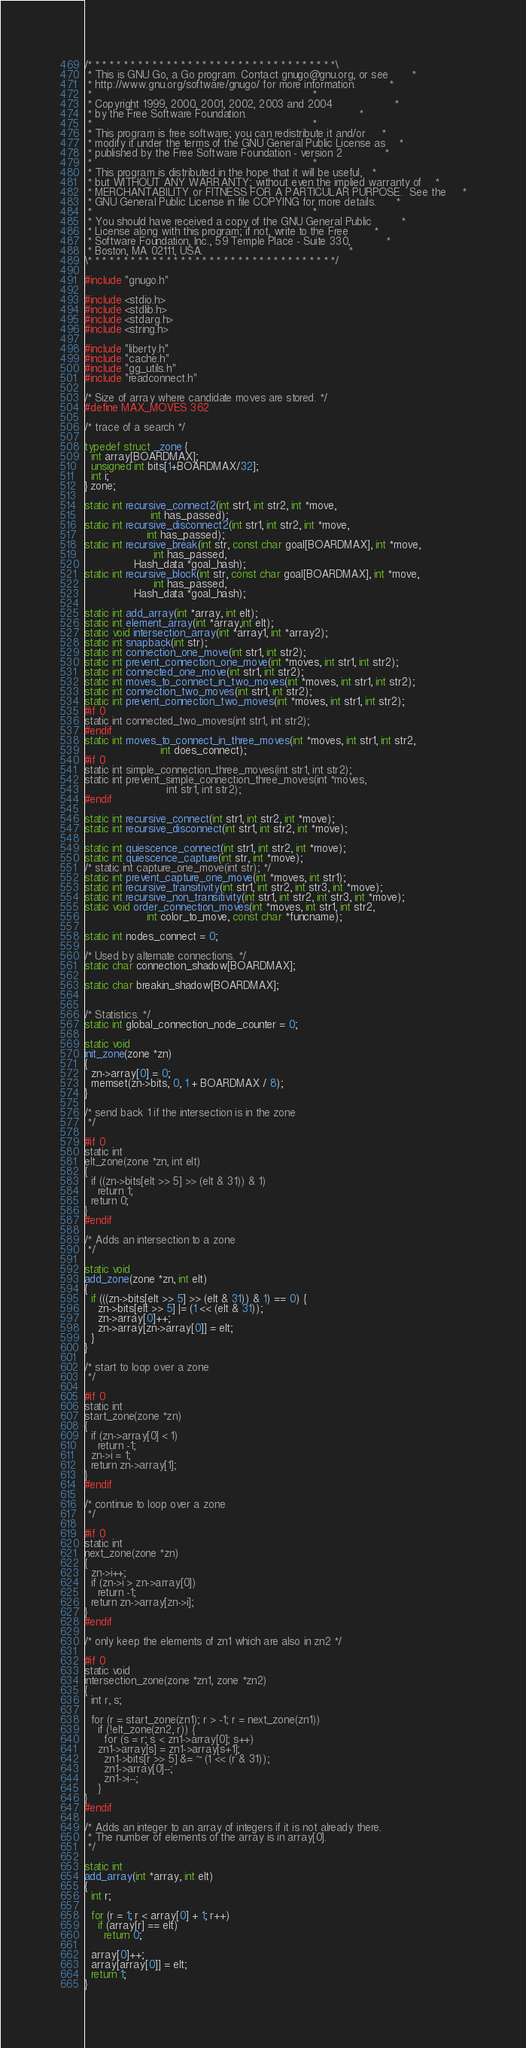Convert code to text. <code><loc_0><loc_0><loc_500><loc_500><_C_>/* * * * * * * * * * * * * * * * * * * * * * * * * * * * * * * * * * *\
 * This is GNU Go, a Go program. Contact gnugo@gnu.org, or see       *
 * http://www.gnu.org/software/gnugo/ for more information.          *
 *                                                                   *
 * Copyright 1999, 2000, 2001, 2002, 2003 and 2004                   *
 * by the Free Software Foundation.                                  *
 *                                                                   *
 * This program is free software; you can redistribute it and/or     *
 * modify it under the terms of the GNU General Public License as    *
 * published by the Free Software Foundation - version 2             *
 *                                                                   *
 * This program is distributed in the hope that it will be useful,   *
 * but WITHOUT ANY WARRANTY; without even the implied warranty of    *
 * MERCHANTABILITY or FITNESS FOR A PARTICULAR PURPOSE.  See the     *
 * GNU General Public License in file COPYING for more details.      *
 *                                                                   *
 * You should have received a copy of the GNU General Public         *
 * License along with this program; if not, write to the Free        *
 * Software Foundation, Inc., 59 Temple Place - Suite 330,           *
 * Boston, MA 02111, USA.                                            *
\* * * * * * * * * * * * * * * * * * * * * * * * * * * * * * * * * * */

#include "gnugo.h"

#include <stdio.h>
#include <stdlib.h>
#include <stdarg.h>
#include <string.h>

#include "liberty.h"
#include "cache.h"
#include "gg_utils.h"
#include "readconnect.h"

/* Size of array where candidate moves are stored. */
#define MAX_MOVES 362

/* trace of a search */

typedef struct _zone {
  int array[BOARDMAX];
  unsigned int bits[1+BOARDMAX/32];
  int i;
} zone;

static int recursive_connect2(int str1, int str2, int *move,
			        int has_passed);
static int recursive_disconnect2(int str1, int str2, int *move,
				   int has_passed);
static int recursive_break(int str, const char goal[BOARDMAX], int *move,
    			     int has_passed,
			   Hash_data *goal_hash);
static int recursive_block(int str, const char goal[BOARDMAX], int *move,
    			     int has_passed,
			   Hash_data *goal_hash);

static int add_array(int *array, int elt);
static int element_array(int *array,int elt);
static void intersection_array(int *array1, int *array2);
static int snapback(int str);
static int connection_one_move(int str1, int str2);
static int prevent_connection_one_move(int *moves, int str1, int str2);
static int connected_one_move(int str1, int str2);
static int moves_to_connect_in_two_moves(int *moves, int str1, int str2);
static int connection_two_moves(int str1, int str2);
static int prevent_connection_two_moves(int *moves, int str1, int str2);
#if 0
static int connected_two_moves(int str1, int str2);
#endif
static int moves_to_connect_in_three_moves(int *moves, int str1, int str2,
					   int does_connect);
#if 0
static int simple_connection_three_moves(int str1, int str2);
static int prevent_simple_connection_three_moves(int *moves,
						 int str1, int str2);
#endif

static int recursive_connect(int str1, int str2, int *move);
static int recursive_disconnect(int str1, int str2, int *move);

static int quiescence_connect(int str1, int str2, int *move);
static int quiescence_capture(int str, int *move);
/* static int capture_one_move(int str); */
static int prevent_capture_one_move(int *moves, int str1);
static int recursive_transitivity(int str1, int str2, int str3, int *move);
static int recursive_non_transitivity(int str1, int str2, int str3, int *move);
static void order_connection_moves(int *moves, int str1, int str2,
				   int color_to_move, const char *funcname);

static int nodes_connect = 0;

/* Used by alternate connections. */
static char connection_shadow[BOARDMAX];

static char breakin_shadow[BOARDMAX];


/* Statistics. */
static int global_connection_node_counter = 0;

static void
init_zone(zone *zn)
{
  zn->array[0] = 0;
  memset(zn->bits, 0, 1 + BOARDMAX / 8);
}

/* send back 1 if the intersection is in the zone
 */

#if 0
static int
elt_zone(zone *zn, int elt)
{
  if ((zn->bits[elt >> 5] >> (elt & 31)) & 1)
    return 1;
  return 0;
}
#endif

/* Adds an intersection to a zone
 */

static void
add_zone(zone *zn, int elt)
{
  if (((zn->bits[elt >> 5] >> (elt & 31)) & 1) == 0) {
    zn->bits[elt >> 5] |= (1 << (elt & 31));
    zn->array[0]++;
    zn->array[zn->array[0]] = elt;
  }
}

/* start to loop over a zone
 */

#if 0
static int
start_zone(zone *zn)
{
  if (zn->array[0] < 1)
    return -1;
  zn->i = 1;
  return zn->array[1];
}
#endif

/* continue to loop over a zone
 */

#if 0
static int
next_zone(zone *zn)
{
  zn->i++;
  if (zn->i > zn->array[0])
    return -1;
  return zn->array[zn->i];
}
#endif

/* only keep the elements of zn1 which are also in zn2 */

#if 0
static void
intersection_zone(zone *zn1, zone *zn2)
{
  int r, s;
  
  for (r = start_zone(zn1); r > -1; r = next_zone(zn1))
    if (!elt_zone(zn2, r)) {
      for (s = r; s < zn1->array[0]; s++)
	zn1->array[s] = zn1->array[s+1];
      zn1->bits[r >> 5] &= ~ (1 << (r & 31));
      zn1->array[0]--;
      zn1->i--;
    }
}
#endif

/* Adds an integer to an array of integers if it is not already there.
 * The number of elements of the array is in array[0].
 */

static int
add_array(int *array, int elt)
{
  int r;
  
  for (r = 1; r < array[0] + 1; r++)
    if (array[r] == elt)
      return 0;

  array[0]++;
  array[array[0]] = elt;
  return 1;
}
</code> 